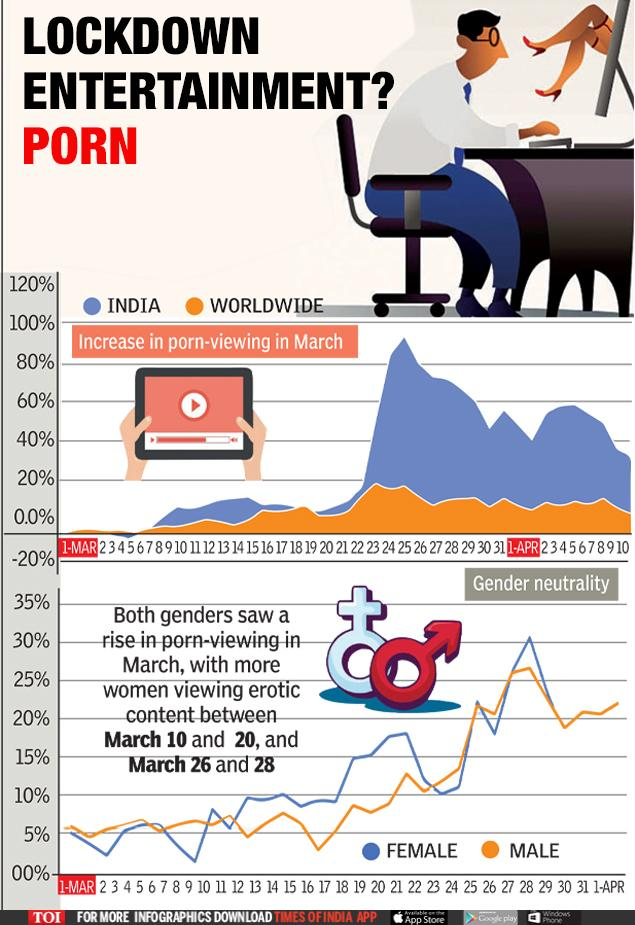Point out several critical features in this image. In the context of representing female gender, blue is commonly used as the color of choice. The color orange is commonly used to represent worldwide. The color orange is used to represent males in a certain context. India is represented by the color blue in certain contexts. 